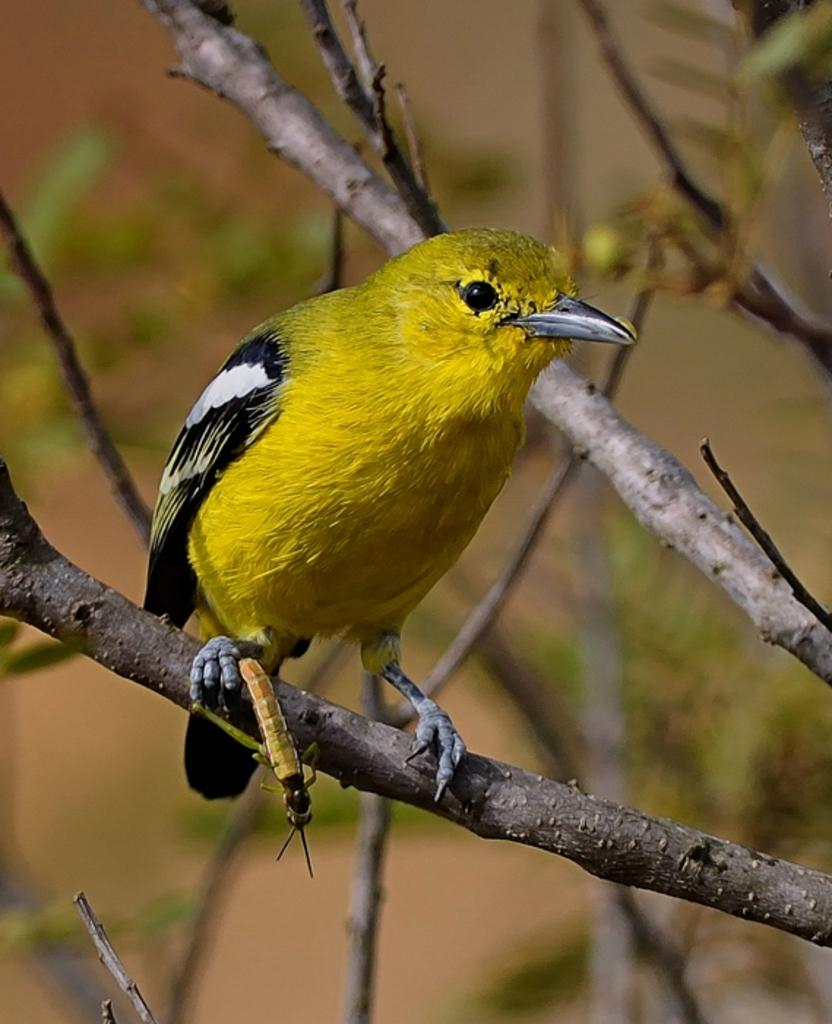What type of animal is in the image? There is a bird in the image. Where is the bird located? The bird is on a stem. Which direction is the bird looking? The bird is looking to the right side. What can be seen in the background of the image? There are many stems visible in the background of the image. What type of pencil is the bird using to write in the image? There is no pencil present in the image, and the bird is not writing. 